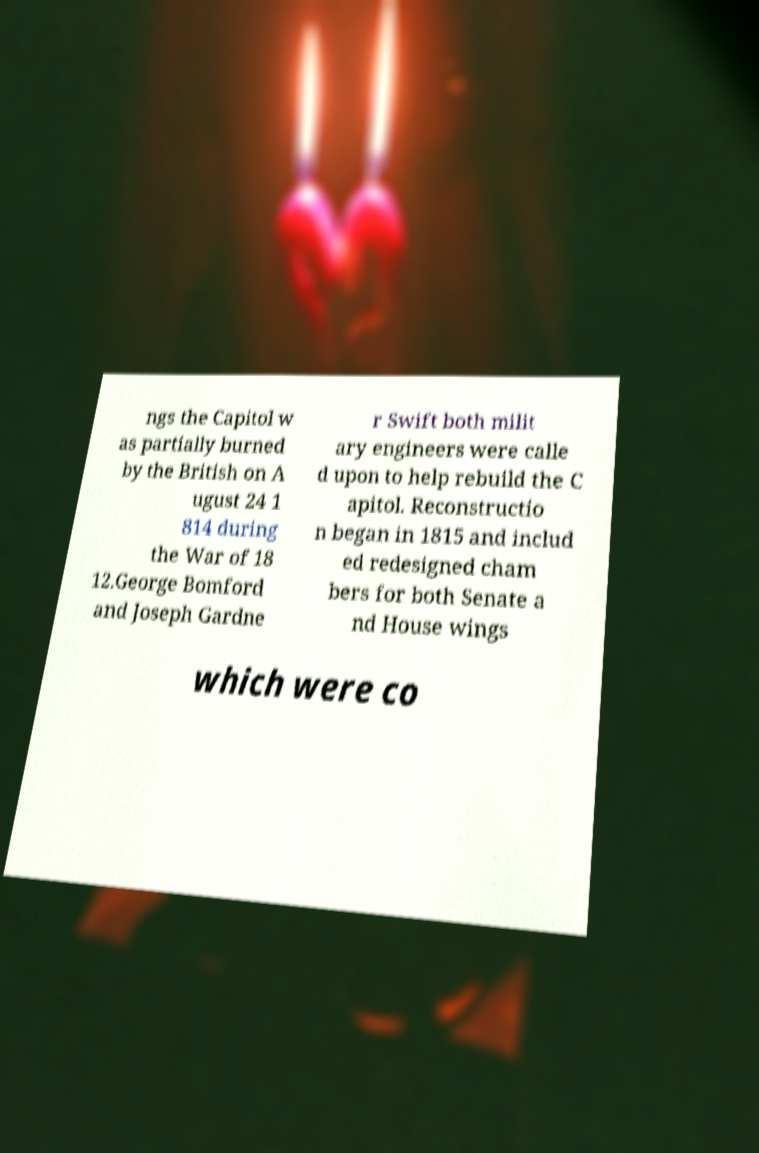Please identify and transcribe the text found in this image. ngs the Capitol w as partially burned by the British on A ugust 24 1 814 during the War of 18 12.George Bomford and Joseph Gardne r Swift both milit ary engineers were calle d upon to help rebuild the C apitol. Reconstructio n began in 1815 and includ ed redesigned cham bers for both Senate a nd House wings which were co 